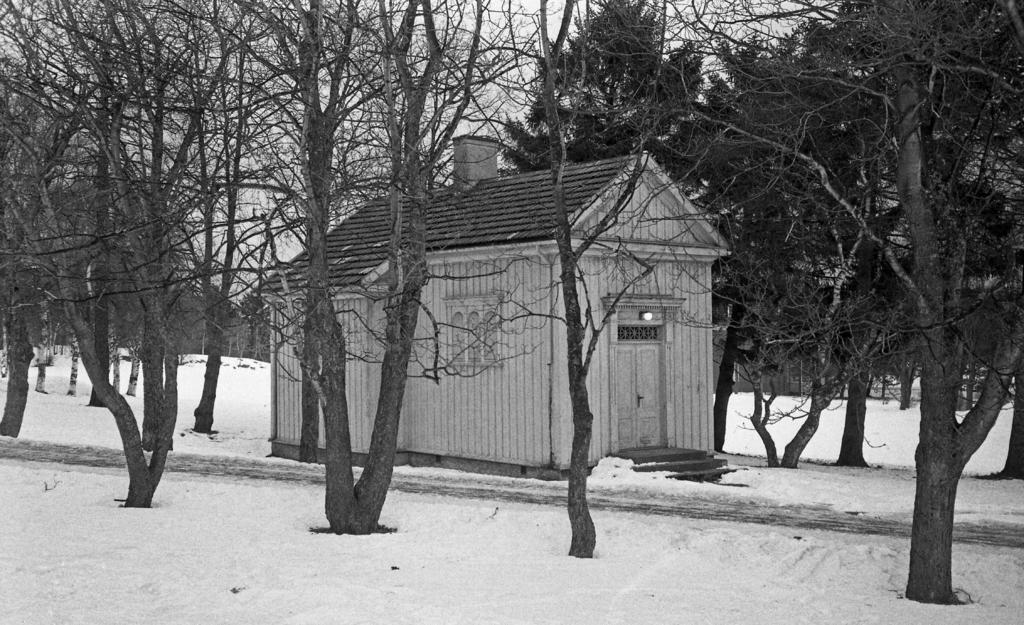What is the color scheme of the image? The image is black and white. What type of structure can be seen in the image? There is a house in the image. What other natural elements are present in the image? There are trees in the image. What is covering the ground in the image? The ground is covered in snow. What can be seen in the background of the image? The sky is visible in the background of the image. What type of teaching is happening in the image? There is no teaching activity depicted in the image. What does the image smell like? The image is a visual representation and does not have a smell. 